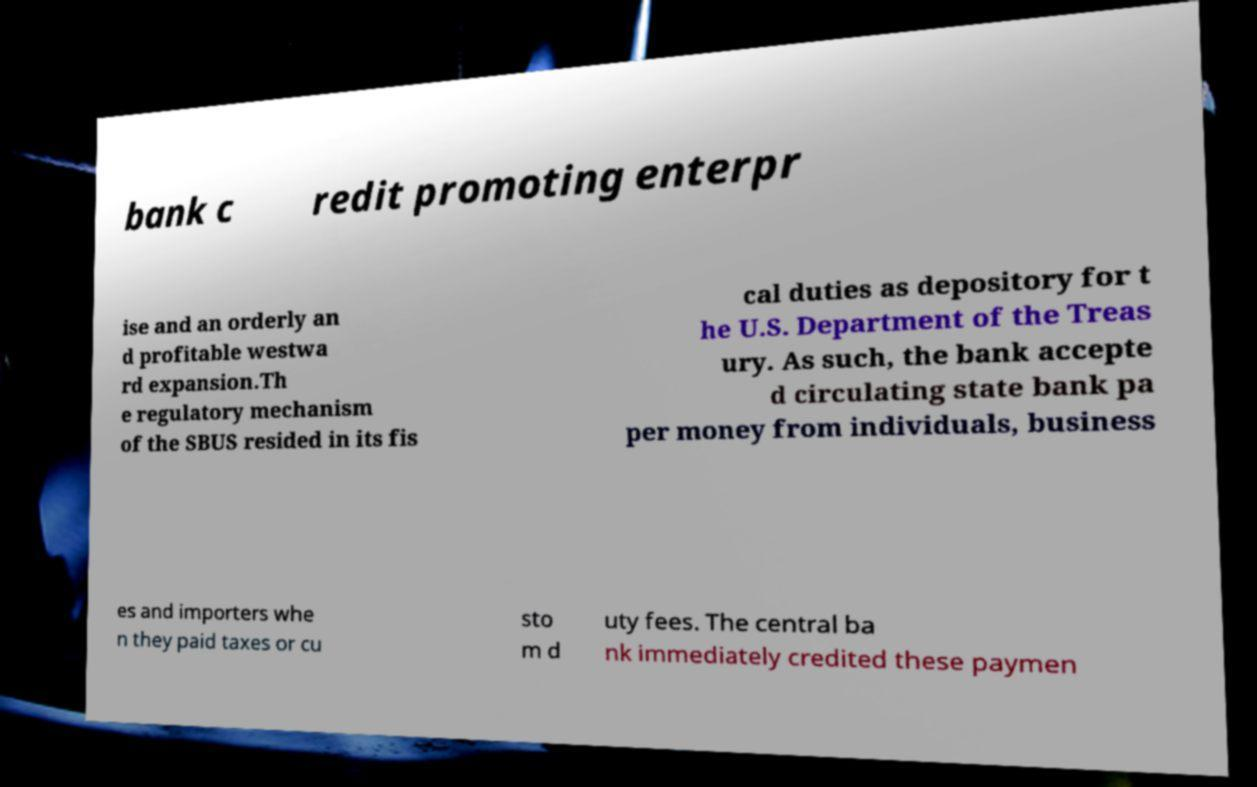Could you extract and type out the text from this image? bank c redit promoting enterpr ise and an orderly an d profitable westwa rd expansion.Th e regulatory mechanism of the SBUS resided in its fis cal duties as depository for t he U.S. Department of the Treas ury. As such, the bank accepte d circulating state bank pa per money from individuals, business es and importers whe n they paid taxes or cu sto m d uty fees. The central ba nk immediately credited these paymen 